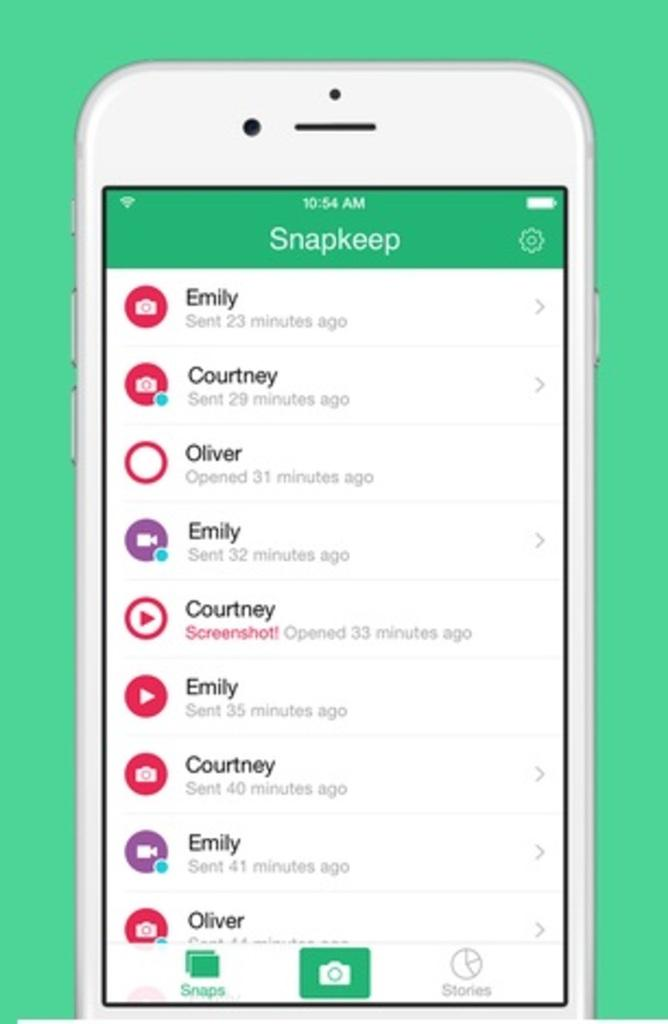<image>
Summarize the visual content of the image. A phone face with SnapKeep open to all of the persons contacts. 